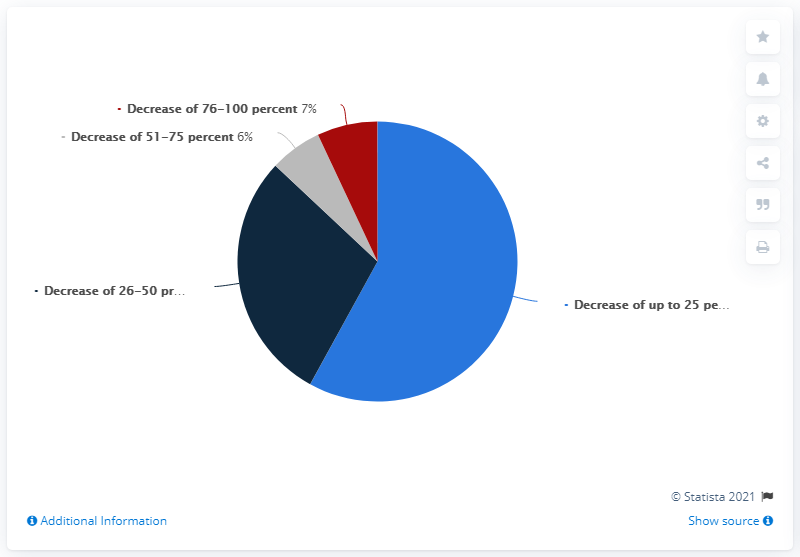Indicate a few pertinent items in this graphic. According to a recent survey, approximately 26-50% of Norwegian production companies experienced a loss during the time period of 2020-2022. Some say that the company's revenue decreased by 76-100 percent compared to the previous year. According to the survey, 6% of respondents reported that the company's revenue decreased by 51% or more compared to the previous year. 